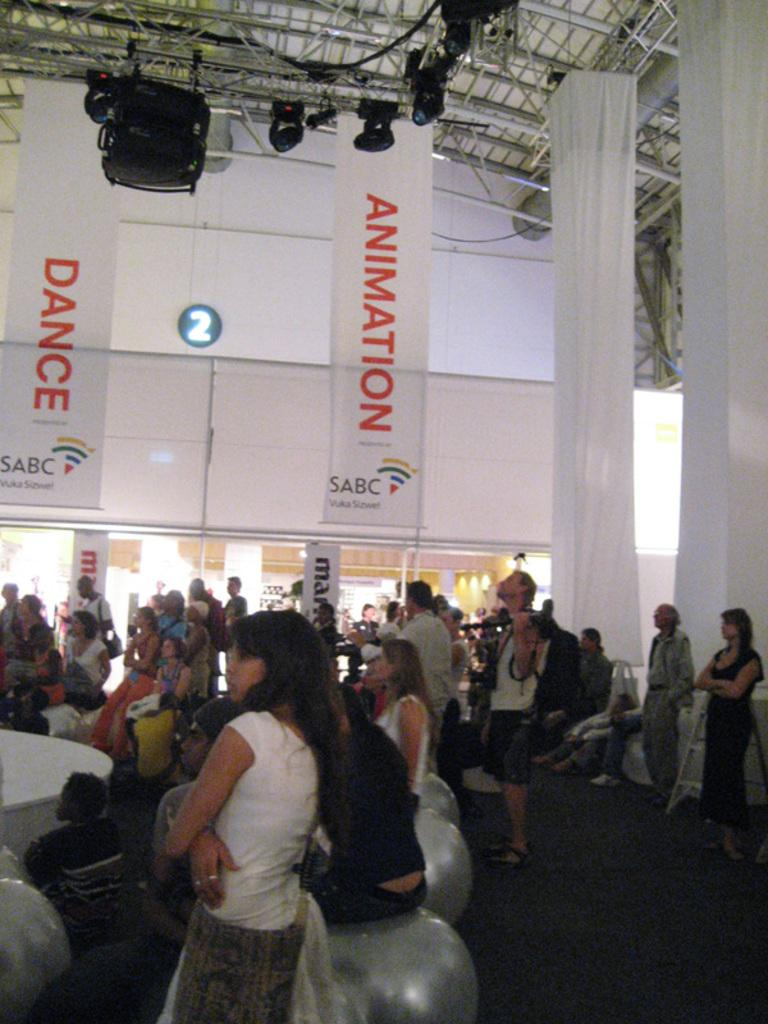What are the people in the image doing? The people in the image are sitting on hopping balls. Are there any people standing in the image? Yes, there are people standing in the image. What can be seen hanging in the image? There are banners visible in the image. What object is used for reaching higher places in the image? There is a ladder in the image. What is visible at the top of the image? There are lights and a shed visible at the top of the image. What type of toys are being played with in the image? There are no toys visible in the image; the people are sitting on hopping balls. What is the shape of the shed at the top of the image? The shape of the shed cannot be determined from the image, as it is not described in the provided facts. 